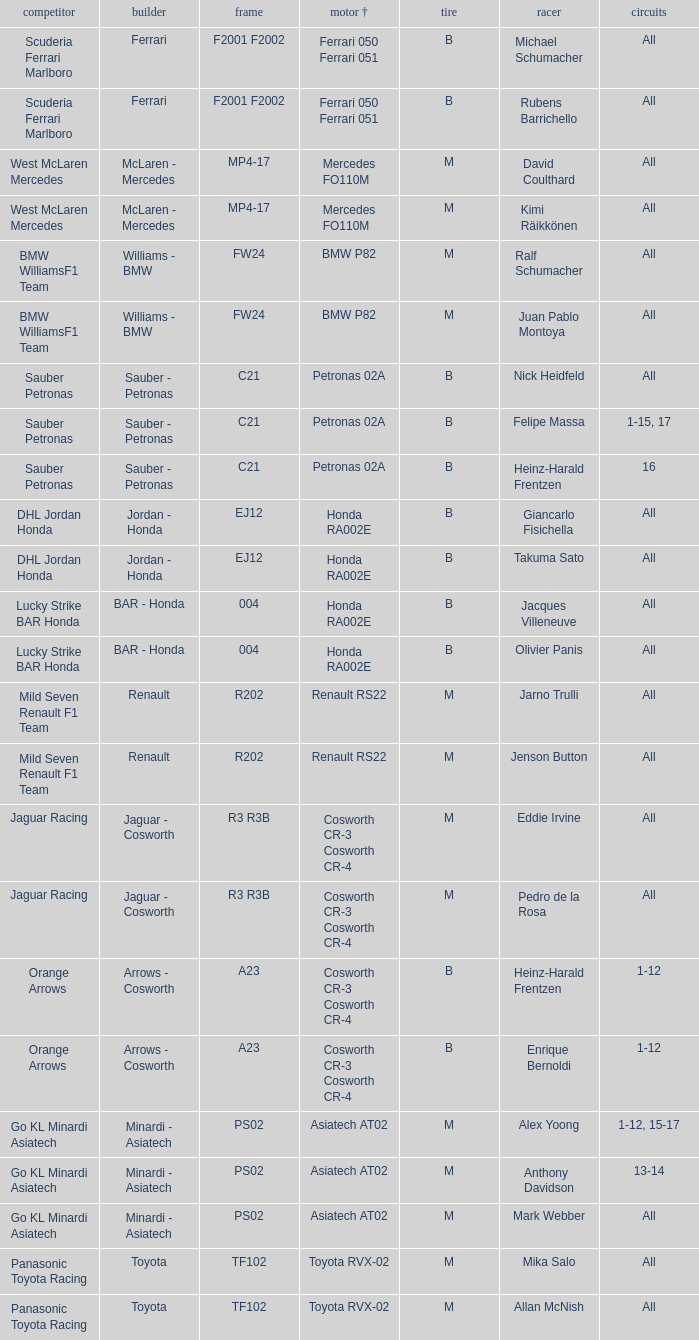Who is the driver when the engine is mercedes fo110m? David Coulthard, Kimi Räikkönen. 